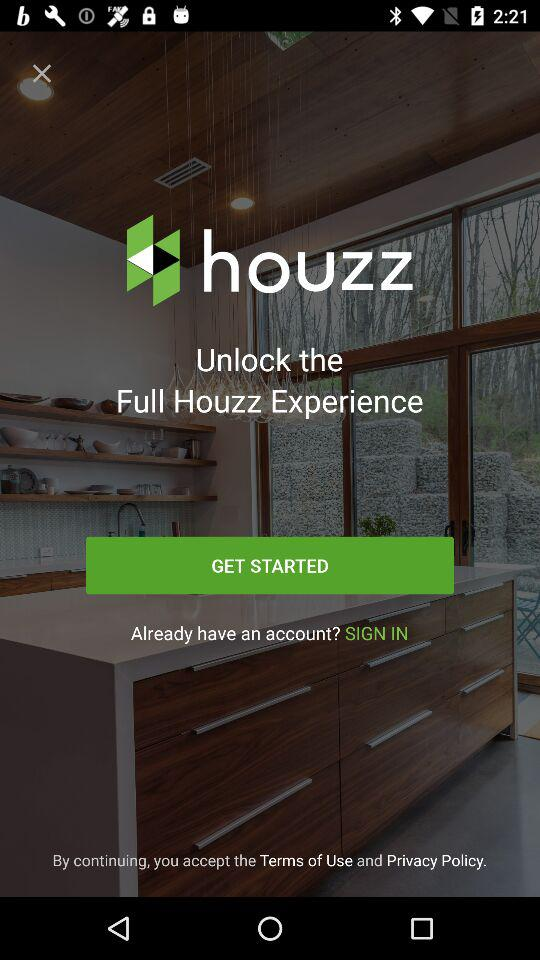Have the terms of use and privacy policy been accepted?
When the provided information is insufficient, respond with <no answer>. <no answer> 